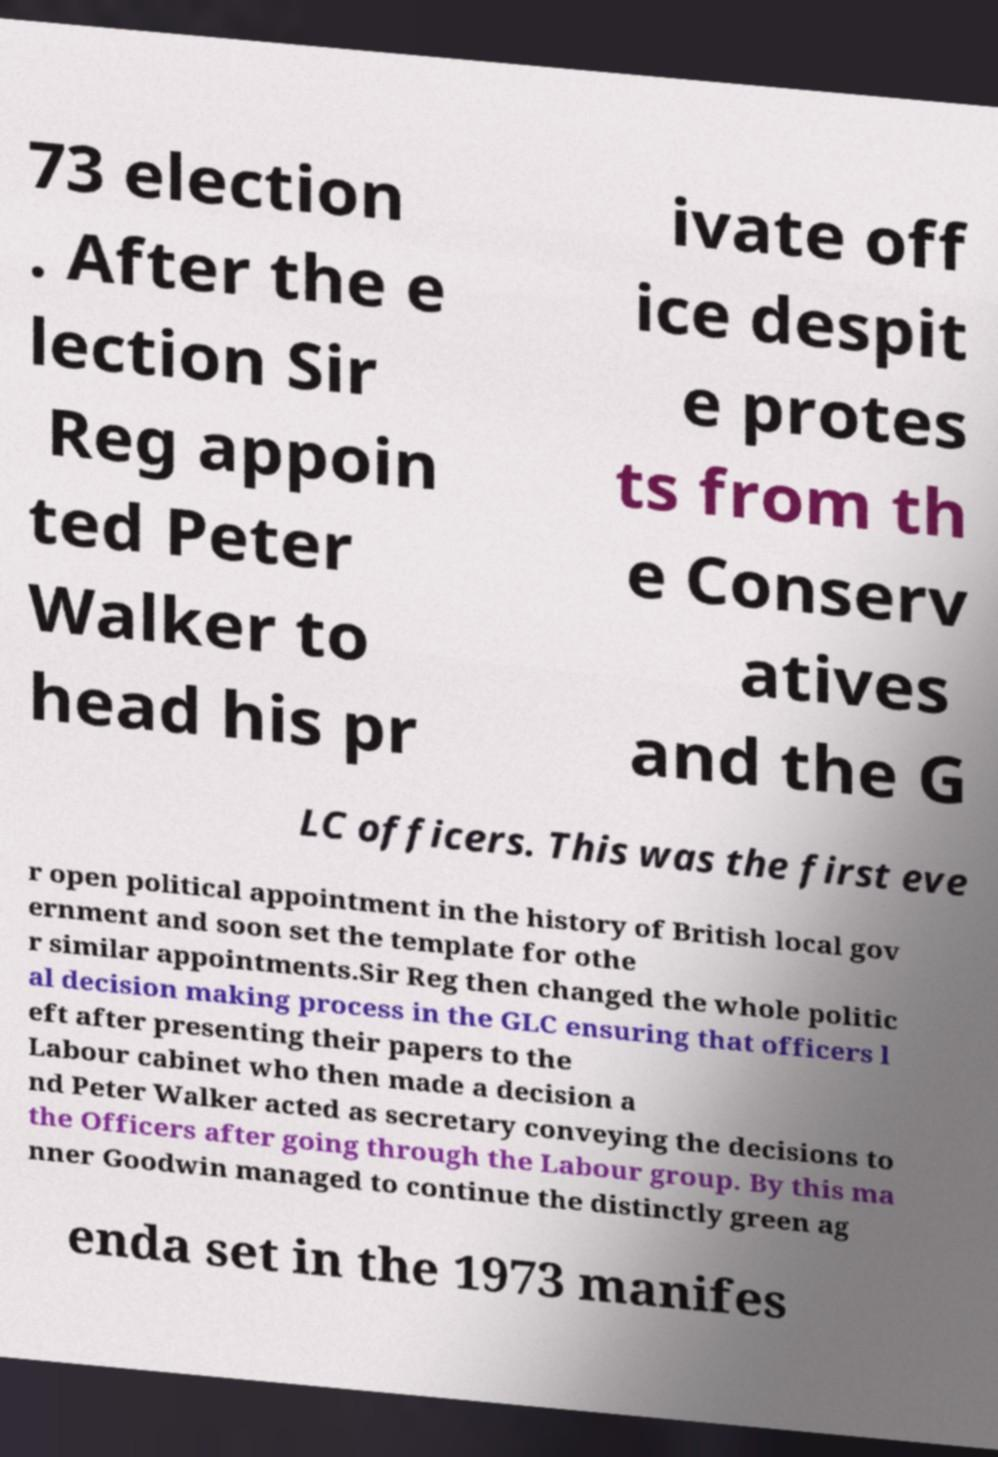Could you assist in decoding the text presented in this image and type it out clearly? 73 election . After the e lection Sir Reg appoin ted Peter Walker to head his pr ivate off ice despit e protes ts from th e Conserv atives and the G LC officers. This was the first eve r open political appointment in the history of British local gov ernment and soon set the template for othe r similar appointments.Sir Reg then changed the whole politic al decision making process in the GLC ensuring that officers l eft after presenting their papers to the Labour cabinet who then made a decision a nd Peter Walker acted as secretary conveying the decisions to the Officers after going through the Labour group. By this ma nner Goodwin managed to continue the distinctly green ag enda set in the 1973 manifes 